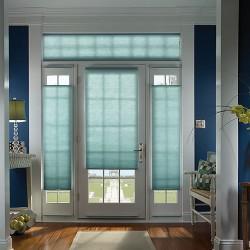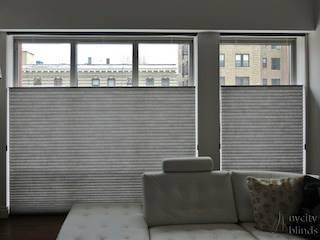The first image is the image on the left, the second image is the image on the right. Analyze the images presented: Is the assertion "One image shows a tufted couch in front of a wide paned window on the left and a narrower window on the right, all with gray shades that don't cover the window tops." valid? Answer yes or no. Yes. The first image is the image on the left, the second image is the image on the right. Assess this claim about the two images: "There are buildings visible through the windows.". Correct or not? Answer yes or no. Yes. 